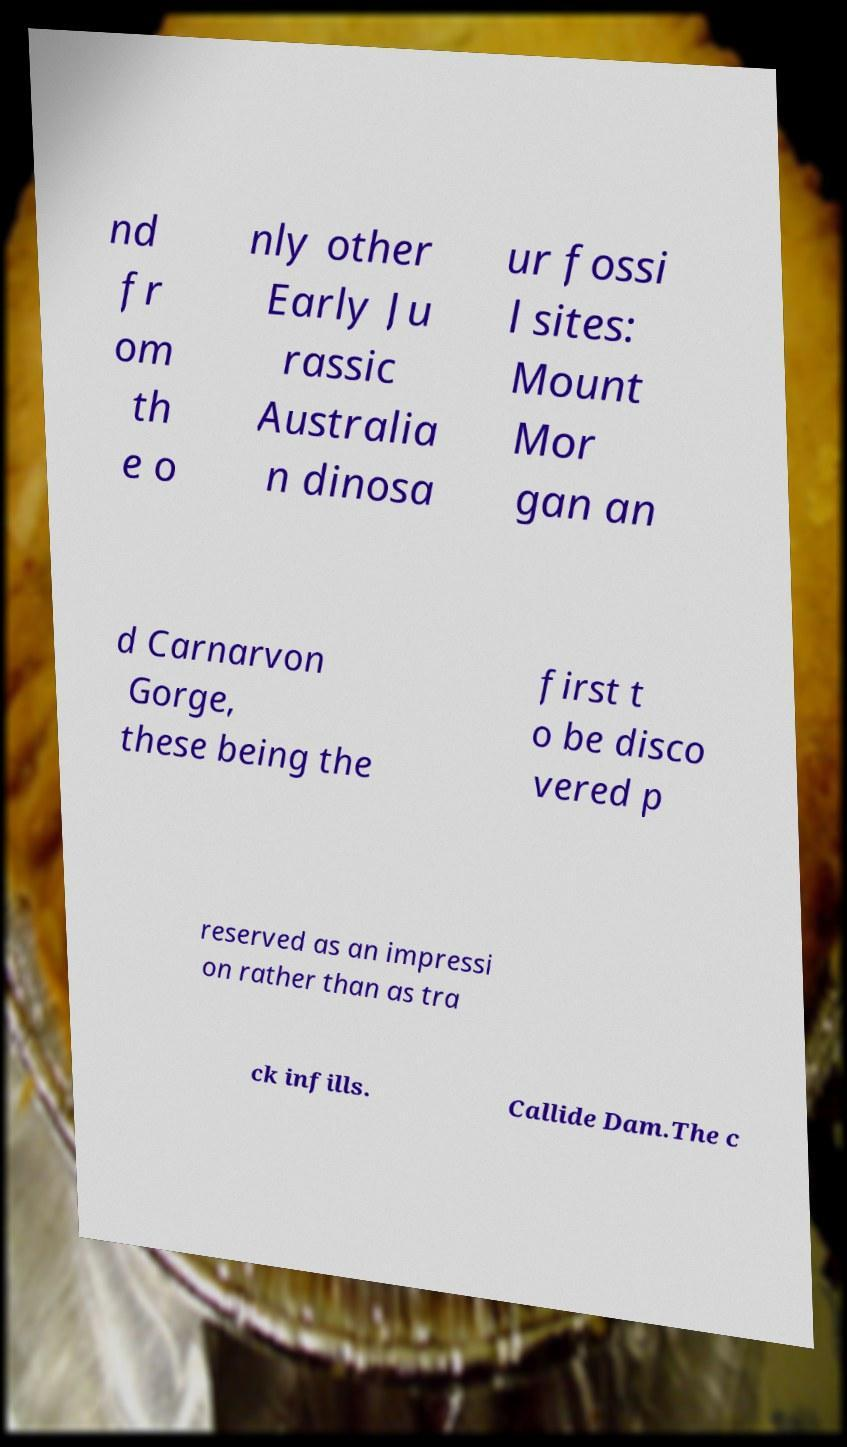There's text embedded in this image that I need extracted. Can you transcribe it verbatim? nd fr om th e o nly other Early Ju rassic Australia n dinosa ur fossi l sites: Mount Mor gan an d Carnarvon Gorge, these being the first t o be disco vered p reserved as an impressi on rather than as tra ck infills. Callide Dam.The c 